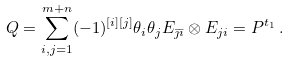Convert formula to latex. <formula><loc_0><loc_0><loc_500><loc_500>Q = \sum _ { i , j = 1 } ^ { m + n } ( - 1 ) ^ { [ i ] [ j ] } \theta _ { i } \theta _ { j } E _ { \bar { \jmath } \bar { \imath } } \otimes E _ { j i } = P ^ { t _ { 1 } } \, .</formula> 